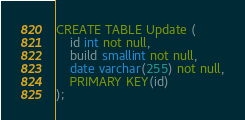Convert code to text. <code><loc_0><loc_0><loc_500><loc_500><_SQL_>CREATE TABLE Update (
    id int not null,
    build smallint not null,
    date varchar(255) not null,
    PRIMARY KEY(id)
);
</code> 